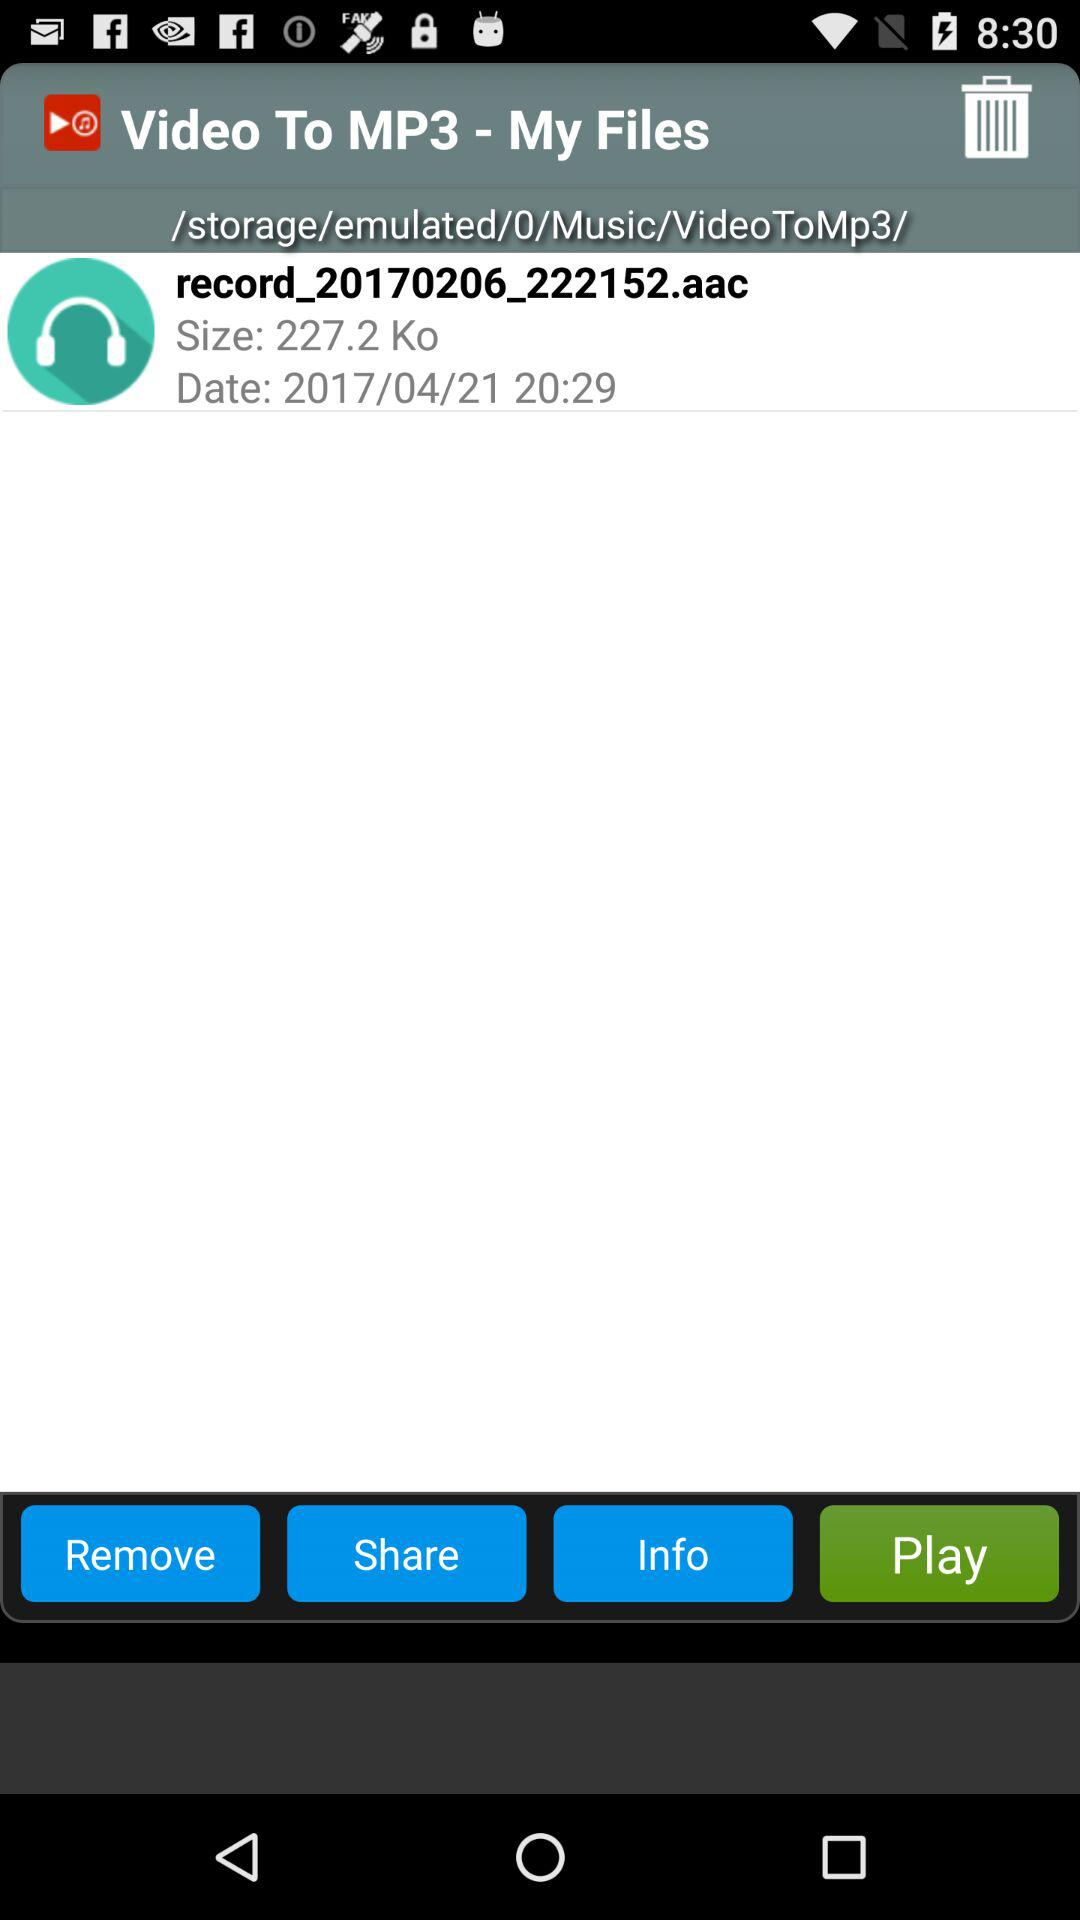How many kilobytes is the file size?
Answer the question using a single word or phrase. 227.2 